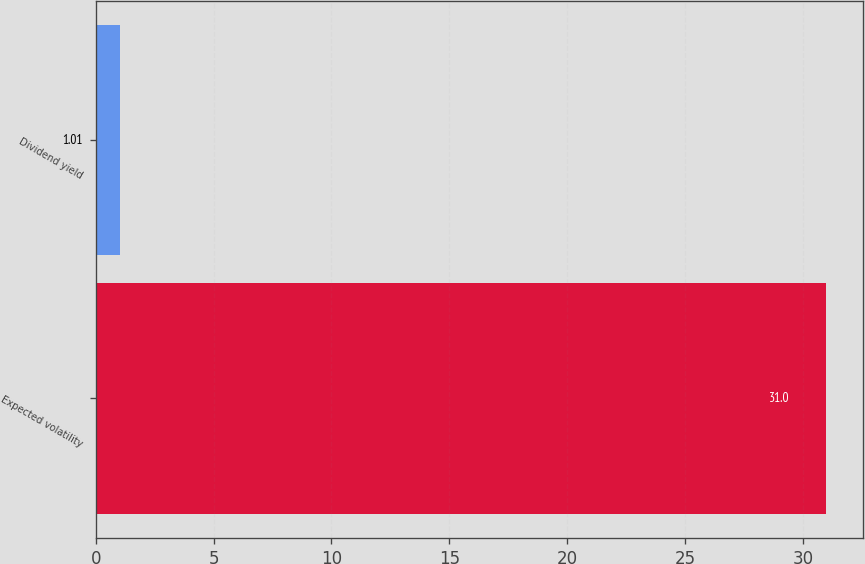Convert chart to OTSL. <chart><loc_0><loc_0><loc_500><loc_500><bar_chart><fcel>Expected volatility<fcel>Dividend yield<nl><fcel>31<fcel>1.01<nl></chart> 